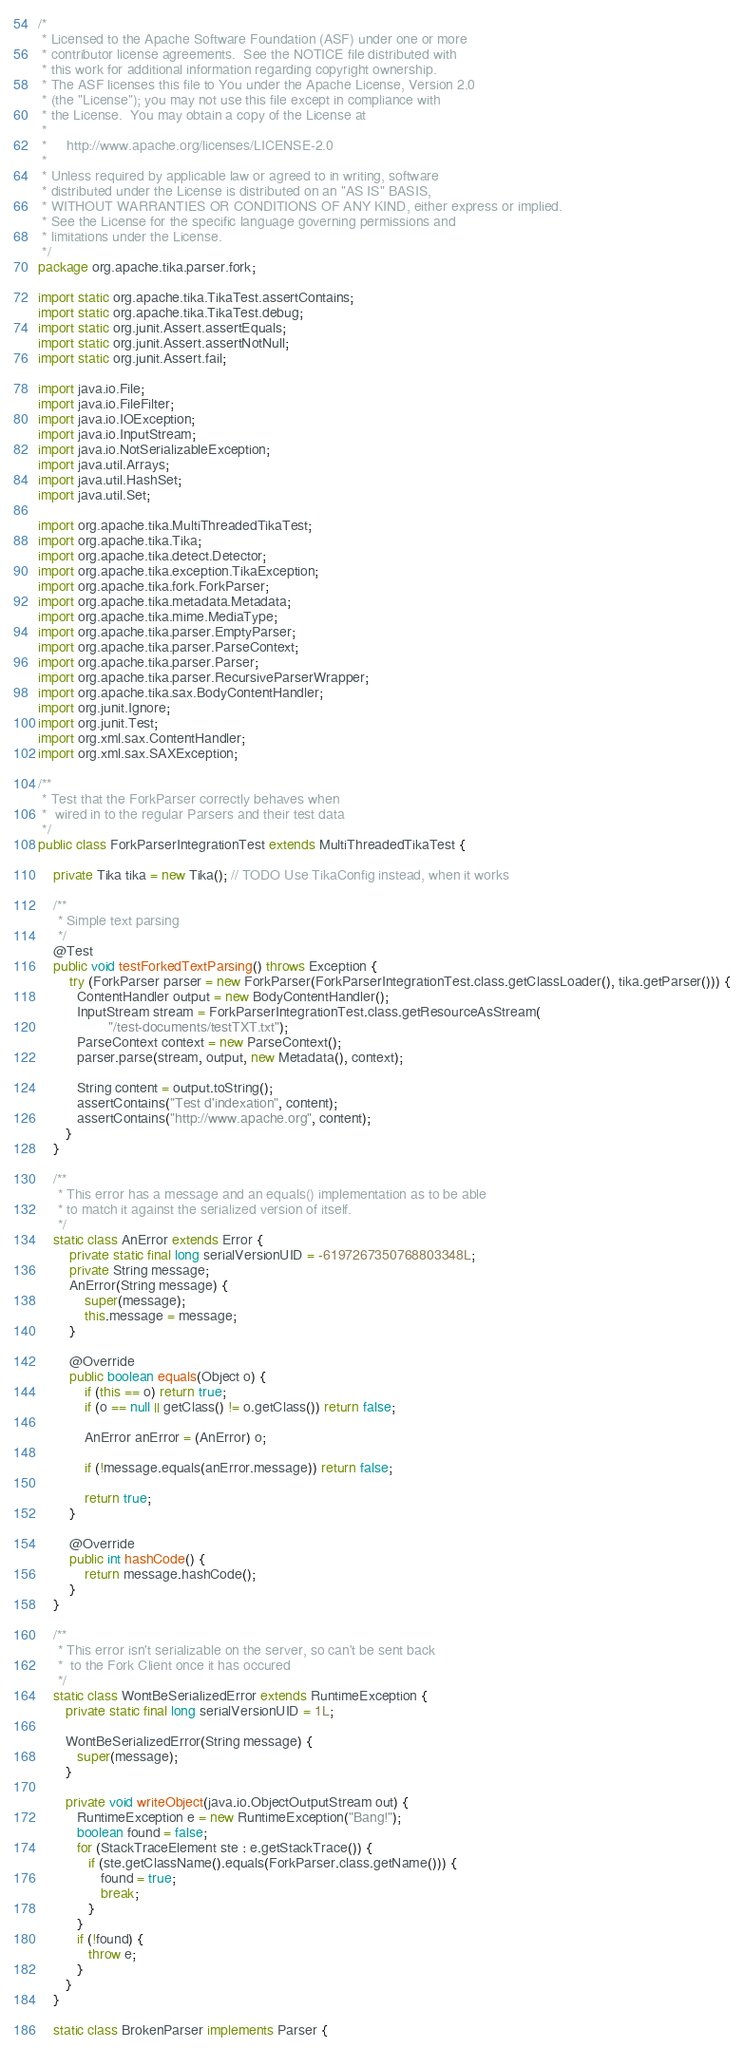Convert code to text. <code><loc_0><loc_0><loc_500><loc_500><_Java_>/*
 * Licensed to the Apache Software Foundation (ASF) under one or more
 * contributor license agreements.  See the NOTICE file distributed with
 * this work for additional information regarding copyright ownership.
 * The ASF licenses this file to You under the Apache License, Version 2.0
 * (the "License"); you may not use this file except in compliance with
 * the License.  You may obtain a copy of the License at
 *
 *     http://www.apache.org/licenses/LICENSE-2.0
 *
 * Unless required by applicable law or agreed to in writing, software
 * distributed under the License is distributed on an "AS IS" BASIS,
 * WITHOUT WARRANTIES OR CONDITIONS OF ANY KIND, either express or implied.
 * See the License for the specific language governing permissions and
 * limitations under the License.
 */
package org.apache.tika.parser.fork;

import static org.apache.tika.TikaTest.assertContains;
import static org.apache.tika.TikaTest.debug;
import static org.junit.Assert.assertEquals;
import static org.junit.Assert.assertNotNull;
import static org.junit.Assert.fail;

import java.io.File;
import java.io.FileFilter;
import java.io.IOException;
import java.io.InputStream;
import java.io.NotSerializableException;
import java.util.Arrays;
import java.util.HashSet;
import java.util.Set;

import org.apache.tika.MultiThreadedTikaTest;
import org.apache.tika.Tika;
import org.apache.tika.detect.Detector;
import org.apache.tika.exception.TikaException;
import org.apache.tika.fork.ForkParser;
import org.apache.tika.metadata.Metadata;
import org.apache.tika.mime.MediaType;
import org.apache.tika.parser.EmptyParser;
import org.apache.tika.parser.ParseContext;
import org.apache.tika.parser.Parser;
import org.apache.tika.parser.RecursiveParserWrapper;
import org.apache.tika.sax.BodyContentHandler;
import org.junit.Ignore;
import org.junit.Test;
import org.xml.sax.ContentHandler;
import org.xml.sax.SAXException;

/**
 * Test that the ForkParser correctly behaves when
 *  wired in to the regular Parsers and their test data
 */
public class ForkParserIntegrationTest extends MultiThreadedTikaTest {

    private Tika tika = new Tika(); // TODO Use TikaConfig instead, when it works

    /**
     * Simple text parsing
     */
    @Test
    public void testForkedTextParsing() throws Exception {
        try (ForkParser parser = new ForkParser(ForkParserIntegrationTest.class.getClassLoader(), tika.getParser())) {
          ContentHandler output = new BodyContentHandler();
          InputStream stream = ForkParserIntegrationTest.class.getResourceAsStream(
                  "/test-documents/testTXT.txt");
          ParseContext context = new ParseContext();
          parser.parse(stream, output, new Metadata(), context);

          String content = output.toString();
          assertContains("Test d'indexation", content);
          assertContains("http://www.apache.org", content);
       }
    }
   
    /**
     * This error has a message and an equals() implementation as to be able 
     * to match it against the serialized version of itself.
     */
    static class AnError extends Error {
        private static final long serialVersionUID = -6197267350768803348L;
        private String message;
        AnError(String message) {
            super(message);
            this.message = message;
        }

        @Override
        public boolean equals(Object o) {
            if (this == o) return true;
            if (o == null || getClass() != o.getClass()) return false;

            AnError anError = (AnError) o;

            if (!message.equals(anError.message)) return false;

            return true;
        }

        @Override
        public int hashCode() {
            return message.hashCode();
        }
    }
    
    /**
     * This error isn't serializable on the server, so can't be sent back
     *  to the Fork Client once it has occured
     */
    static class WontBeSerializedError extends RuntimeException {
       private static final long serialVersionUID = 1L;

       WontBeSerializedError(String message) {
          super(message);
       }

       private void writeObject(java.io.ObjectOutputStream out) {
          RuntimeException e = new RuntimeException("Bang!");
          boolean found = false;
          for (StackTraceElement ste : e.getStackTrace()) {
             if (ste.getClassName().equals(ForkParser.class.getName())) {
                found = true;
                break;
             }
          }
          if (!found) {
             throw e;
          }
       }
    }
    
    static class BrokenParser implements Parser {</code> 